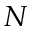Convert formula to latex. <formula><loc_0><loc_0><loc_500><loc_500>N</formula> 